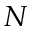Convert formula to latex. <formula><loc_0><loc_0><loc_500><loc_500>N</formula> 